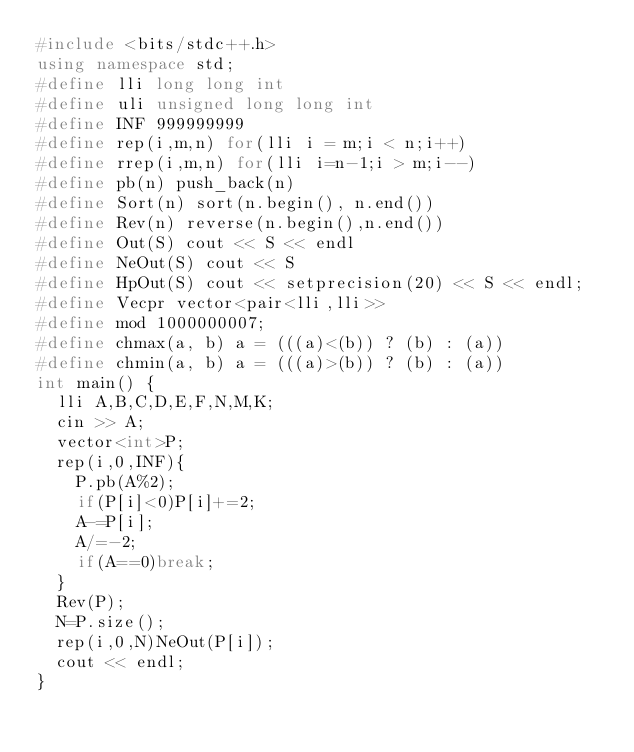<code> <loc_0><loc_0><loc_500><loc_500><_C++_>#include <bits/stdc++.h>
using namespace std;
#define lli long long int
#define uli unsigned long long int
#define INF 999999999
#define rep(i,m,n) for(lli i = m;i < n;i++)
#define rrep(i,m,n) for(lli i=n-1;i > m;i--)
#define pb(n) push_back(n)
#define Sort(n) sort(n.begin(), n.end())
#define Rev(n) reverse(n.begin(),n.end())
#define Out(S) cout << S << endl
#define NeOut(S) cout << S
#define HpOut(S) cout << setprecision(20) << S << endl;
#define Vecpr vector<pair<lli,lli>>
#define mod 1000000007;
#define chmax(a, b) a = (((a)<(b)) ? (b) : (a))
#define chmin(a, b) a = (((a)>(b)) ? (b) : (a))
int main() {
  lli A,B,C,D,E,F,N,M,K;
  cin >> A;
  vector<int>P;
  rep(i,0,INF){
    P.pb(A%2);
    if(P[i]<0)P[i]+=2;
    A-=P[i];
    A/=-2;
    if(A==0)break;
  }
  Rev(P);
  N=P.size();
  rep(i,0,N)NeOut(P[i]);
  cout << endl;
} </code> 